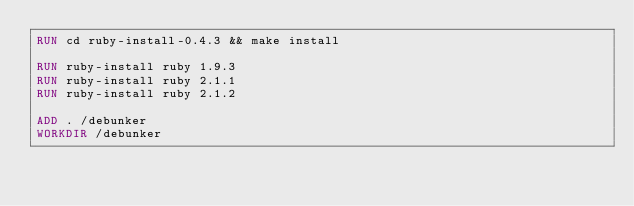<code> <loc_0><loc_0><loc_500><loc_500><_Dockerfile_>RUN cd ruby-install-0.4.3 && make install

RUN ruby-install ruby 1.9.3
RUN ruby-install ruby 2.1.1
RUN ruby-install ruby 2.1.2

ADD . /debunker
WORKDIR /debunker
</code> 